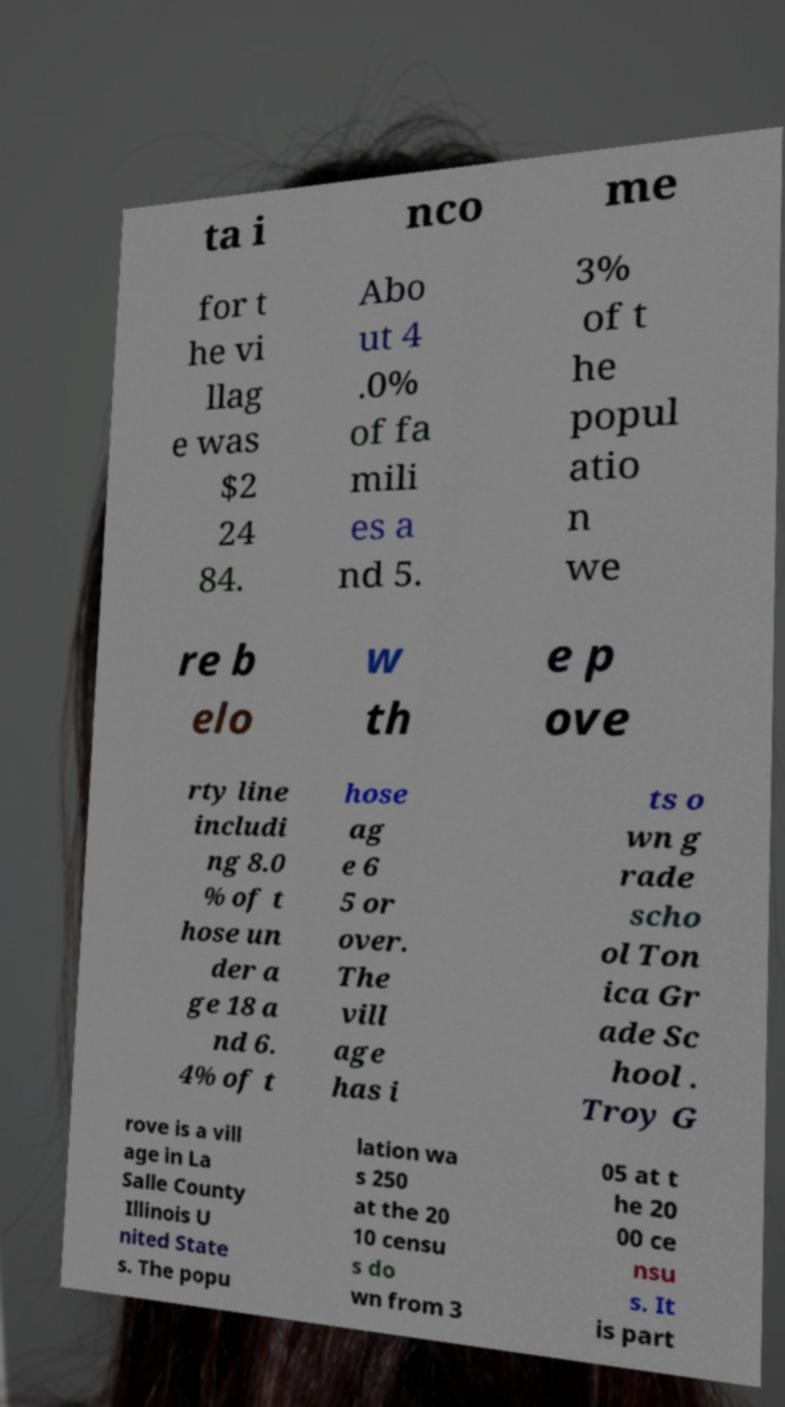Please identify and transcribe the text found in this image. ta i nco me for t he vi llag e was $2 24 84. Abo ut 4 .0% of fa mili es a nd 5. 3% of t he popul atio n we re b elo w th e p ove rty line includi ng 8.0 % of t hose un der a ge 18 a nd 6. 4% of t hose ag e 6 5 or over. The vill age has i ts o wn g rade scho ol Ton ica Gr ade Sc hool . Troy G rove is a vill age in La Salle County Illinois U nited State s. The popu lation wa s 250 at the 20 10 censu s do wn from 3 05 at t he 20 00 ce nsu s. It is part 